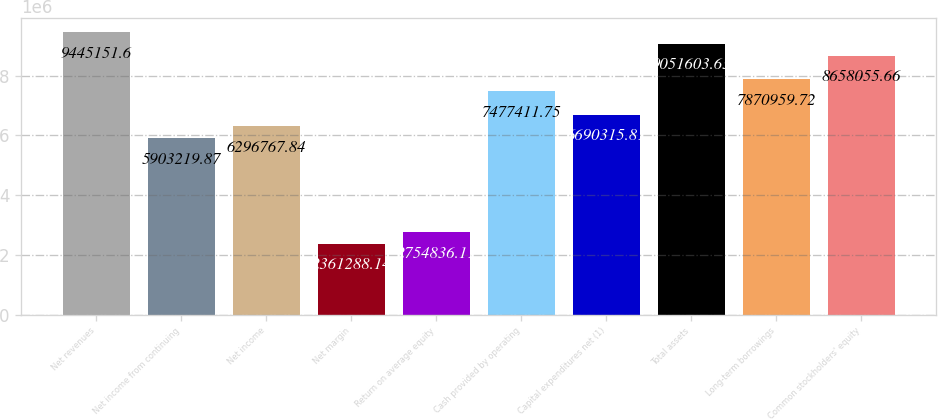Convert chart. <chart><loc_0><loc_0><loc_500><loc_500><bar_chart><fcel>Net revenues<fcel>Net income from continuing<fcel>Net income<fcel>Net margin<fcel>Return on average equity<fcel>Cash provided by operating<fcel>Capital expenditures net (1)<fcel>Total assets<fcel>Long-term borrowings<fcel>Common stockholders' equity<nl><fcel>9.44515e+06<fcel>5.90322e+06<fcel>6.29677e+06<fcel>2.36129e+06<fcel>2.75484e+06<fcel>7.47741e+06<fcel>6.69032e+06<fcel>9.0516e+06<fcel>7.87096e+06<fcel>8.65806e+06<nl></chart> 